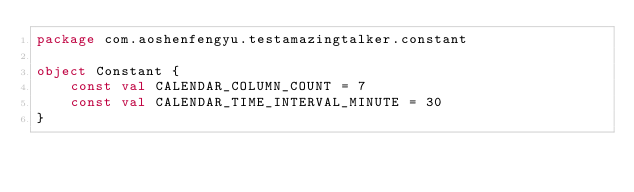Convert code to text. <code><loc_0><loc_0><loc_500><loc_500><_Kotlin_>package com.aoshenfengyu.testamazingtalker.constant

object Constant {
    const val CALENDAR_COLUMN_COUNT = 7
    const val CALENDAR_TIME_INTERVAL_MINUTE = 30
}</code> 